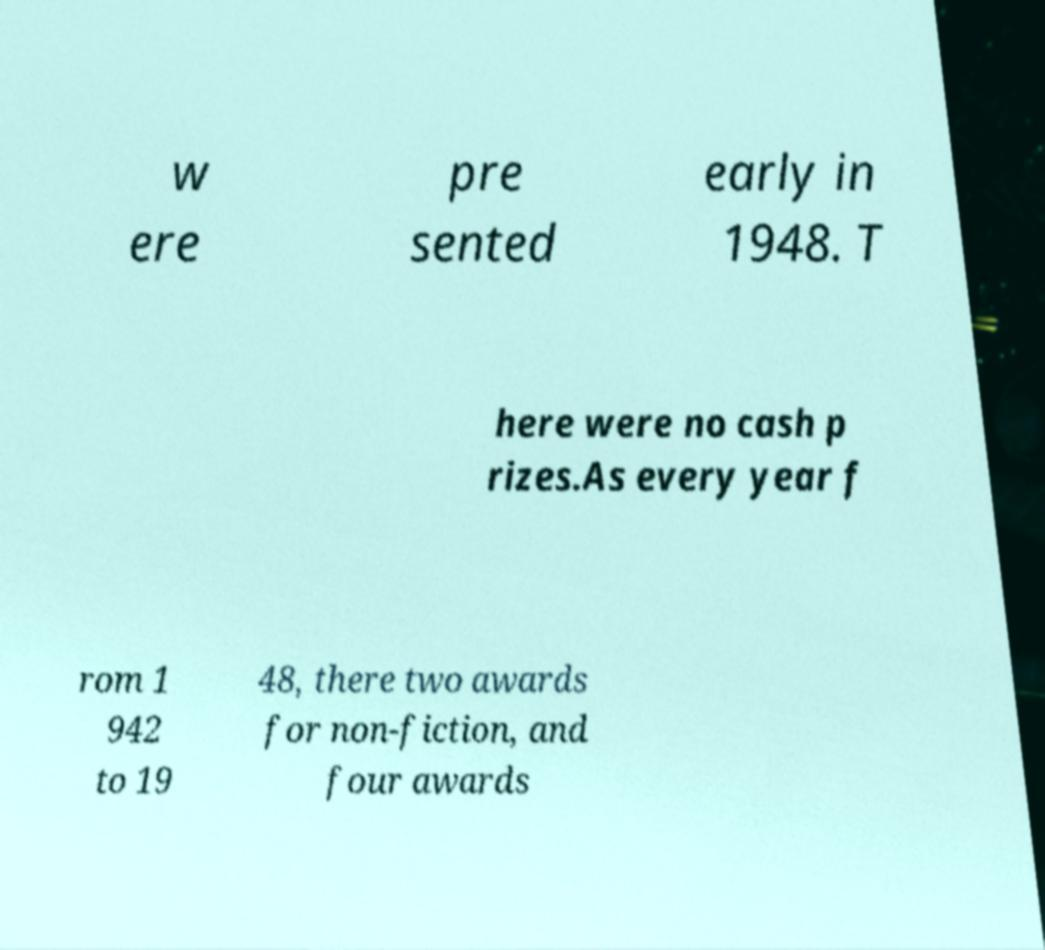Please identify and transcribe the text found in this image. w ere pre sented early in 1948. T here were no cash p rizes.As every year f rom 1 942 to 19 48, there two awards for non-fiction, and four awards 